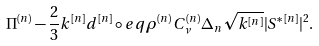Convert formula to latex. <formula><loc_0><loc_0><loc_500><loc_500>\Pi ^ { ( n ) } - \frac { 2 } { 3 } k ^ { [ n ] } d ^ { [ n ] } \circ e q \rho ^ { ( n ) } C _ { \nu } ^ { ( n ) } \Delta _ { n } \sqrt { k ^ { [ n ] } } | S ^ { \ast \, [ n ] } | ^ { 2 } .</formula> 